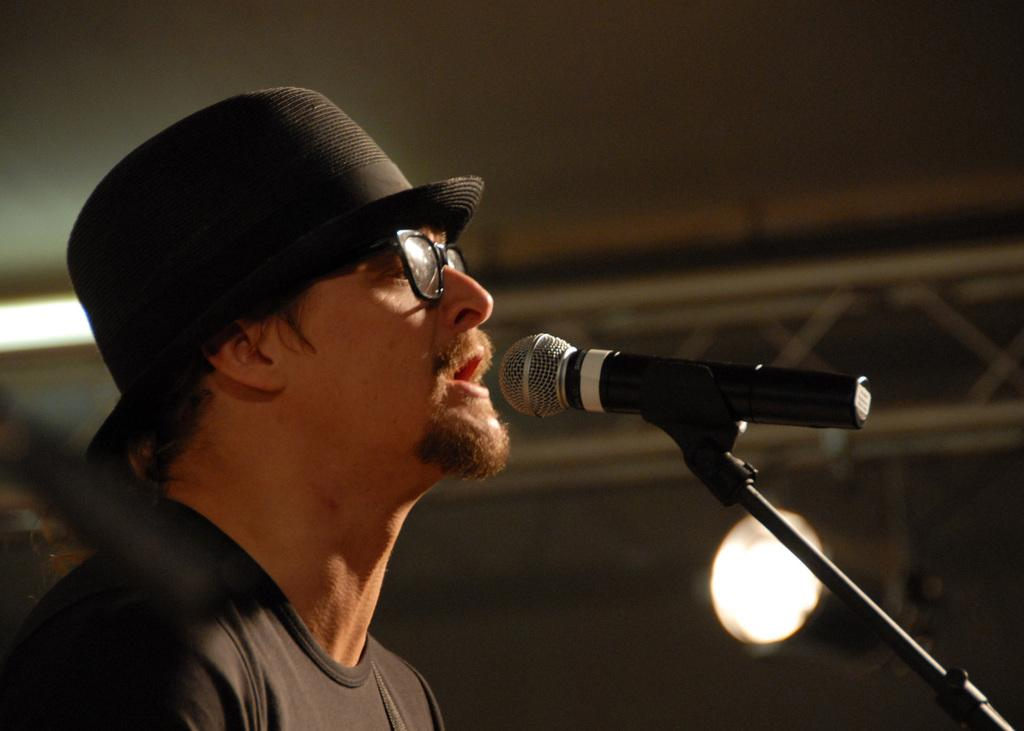What is the main subject of the image? There is a person in the image. What is the person wearing on his upper body? The person is wearing a black shirt. What is the person wearing on his head? The person is wearing a black cap on his head. What accessory is the person wearing on his face? The person is wearing spectacles. What object is in front of the person? There is a microphone in front of the person. How many tickets are visible in the image? There are no tickets present in the image. What type of pump is being used by the person in the image? There is no pump visible in the image. 